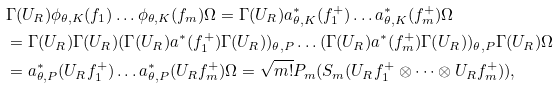<formula> <loc_0><loc_0><loc_500><loc_500>& \Gamma ( U _ { R } ) \phi _ { \theta , K } ( f _ { 1 } ) \dots \phi _ { \theta , K } ( f _ { m } ) \Omega = \Gamma ( U _ { R } ) a _ { \theta , K } ^ { * } ( f ^ { + } _ { 1 } ) \dots a _ { \theta , K } ^ { * } ( f ^ { + } _ { m } ) \Omega \\ & = \Gamma ( U _ { R } ) \Gamma ( U _ { R } ) ( \Gamma ( U _ { R } ) a ^ { * } ( f ^ { + } _ { 1 } ) \Gamma ( U _ { R } ) ) _ { \theta , P } \dots ( \Gamma ( U _ { R } ) a ^ { * } ( f ^ { + } _ { m } ) \Gamma ( U _ { R } ) ) _ { \theta , P } \Gamma ( U _ { R } ) \Omega \\ & = a _ { \theta , P } ^ { * } ( U _ { R } f ^ { + } _ { 1 } ) \dots a _ { \theta , P } ^ { * } ( U _ { R } f ^ { + } _ { m } ) \Omega = \sqrt { m ! } P _ { m } ( S _ { m } ( U _ { R } f ^ { + } _ { 1 } \otimes \dots \otimes U _ { R } f ^ { + } _ { m } ) ) ,</formula> 